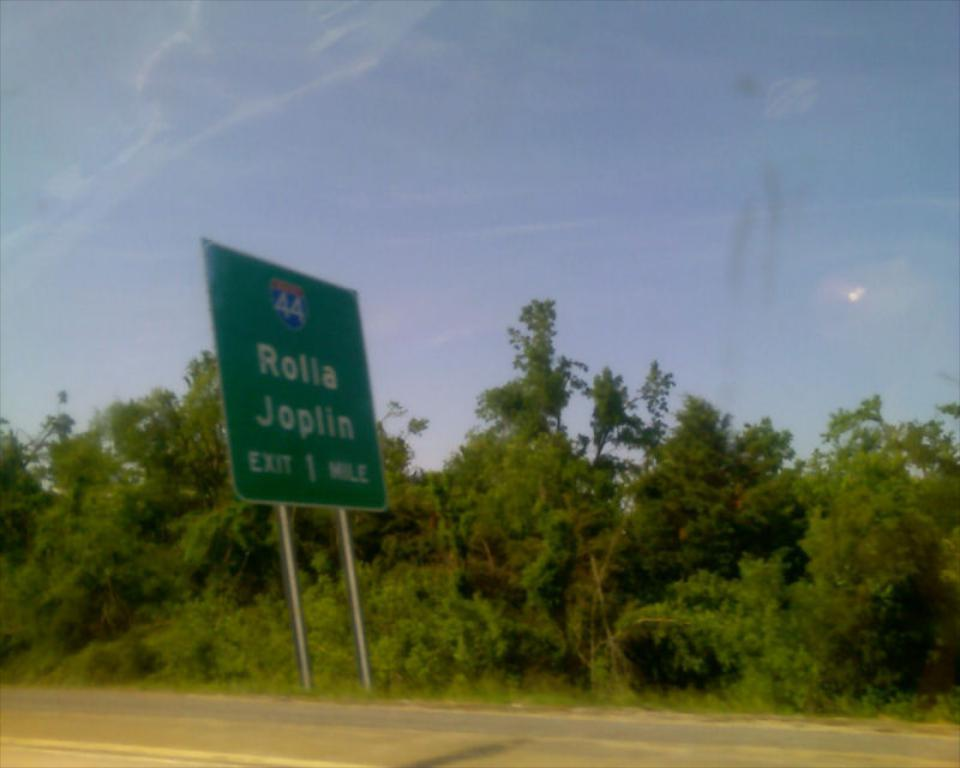What is placed side to the road in the foreground of the image? There is a board placed side to the road in the foreground of the image. What can be seen in the background of the image? There are trees and the sky visible in the background of the image. What is the condition of the sky in the image? The sky is visible in the background of the image, and there are clouds present. Can you see a cat walking on the floor in the image? There is no cat or floor visible in the image; it features a board placed side to the road and a background with trees and the sky. 